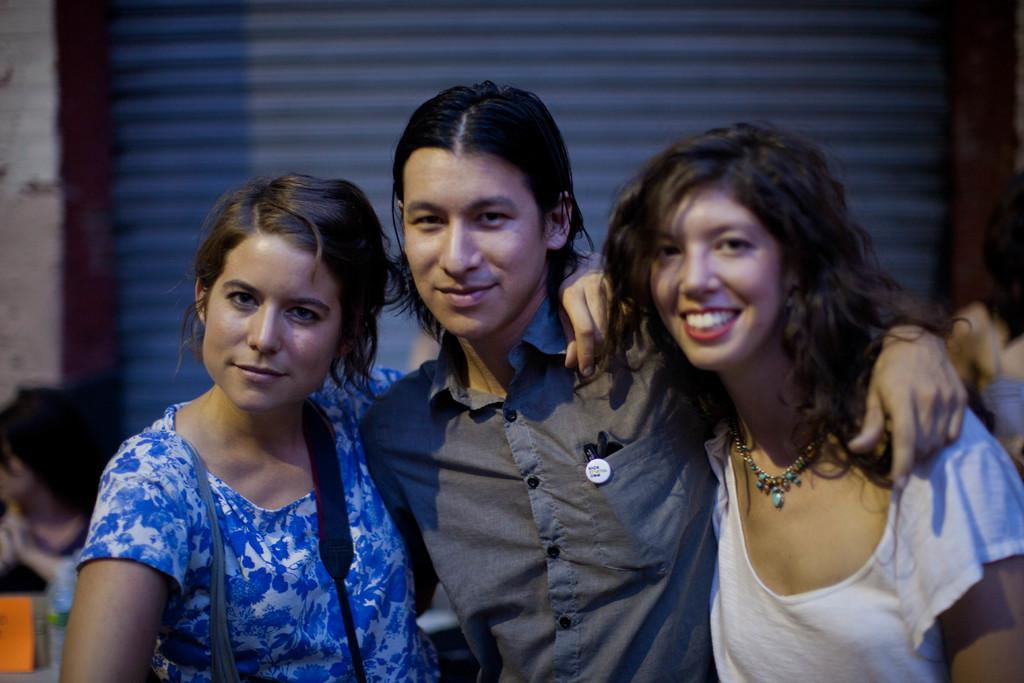How many people are standing in the image? There are two women and a man standing in the image. Are there any people sitting in the image? Yes, there is a woman and a man sitting in the background of the image. What can be seen in the background of the image? There appears to be a metal shutter in the background of the image. What is the caption of the image? There is no caption present in the image. What game are the people playing in the image? There is no game being played in the image; it simply shows people standing and sitting. 